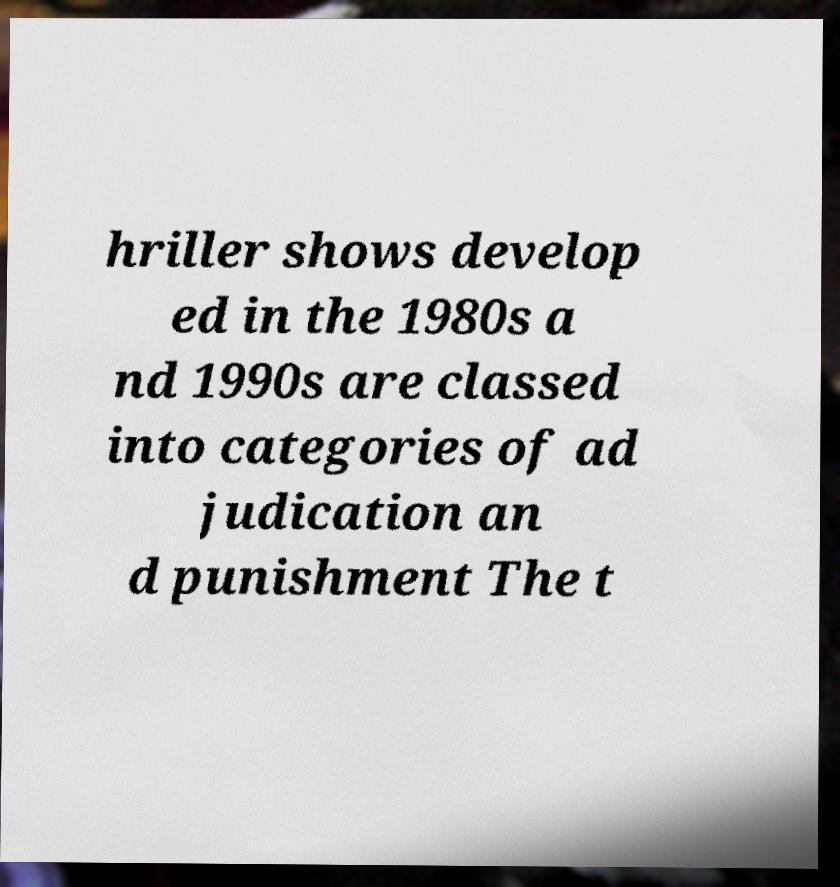For documentation purposes, I need the text within this image transcribed. Could you provide that? hriller shows develop ed in the 1980s a nd 1990s are classed into categories of ad judication an d punishment The t 